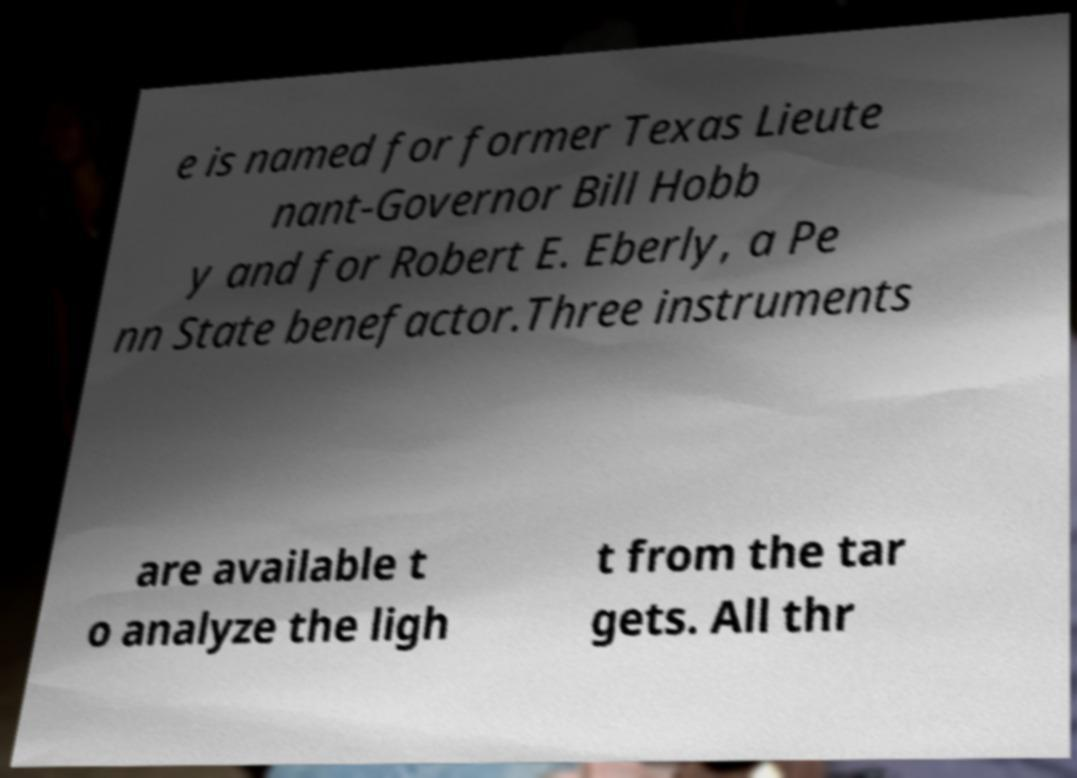I need the written content from this picture converted into text. Can you do that? e is named for former Texas Lieute nant-Governor Bill Hobb y and for Robert E. Eberly, a Pe nn State benefactor.Three instruments are available t o analyze the ligh t from the tar gets. All thr 